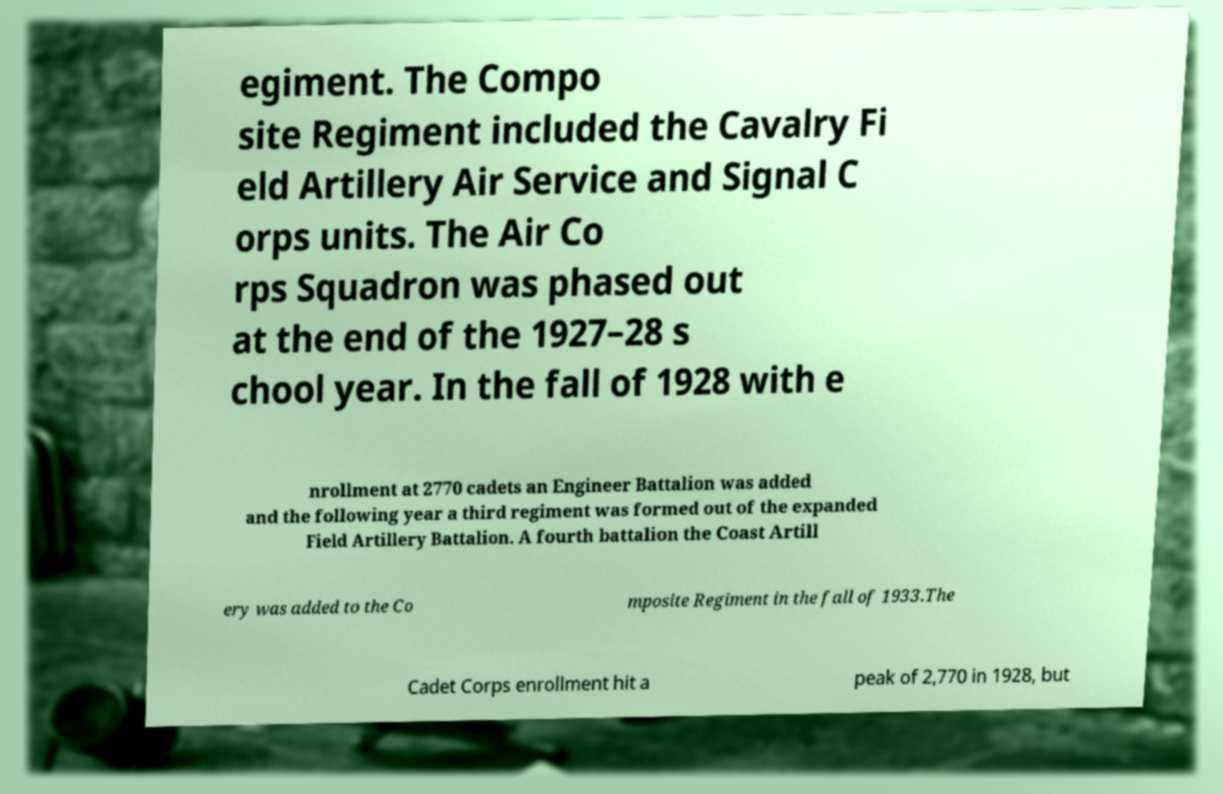What messages or text are displayed in this image? I need them in a readable, typed format. egiment. The Compo site Regiment included the Cavalry Fi eld Artillery Air Service and Signal C orps units. The Air Co rps Squadron was phased out at the end of the 1927–28 s chool year. In the fall of 1928 with e nrollment at 2770 cadets an Engineer Battalion was added and the following year a third regiment was formed out of the expanded Field Artillery Battalion. A fourth battalion the Coast Artill ery was added to the Co mposite Regiment in the fall of 1933.The Cadet Corps enrollment hit a peak of 2,770 in 1928, but 